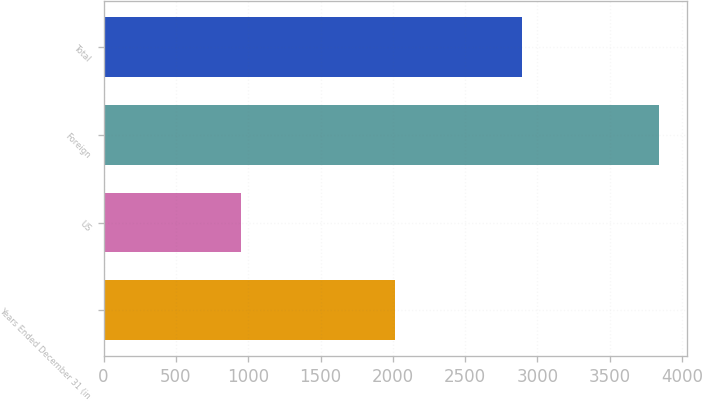Convert chart. <chart><loc_0><loc_0><loc_500><loc_500><bar_chart><fcel>Years Ended December 31 (in<fcel>US<fcel>Foreign<fcel>Total<nl><fcel>2012<fcel>948<fcel>3839<fcel>2891<nl></chart> 